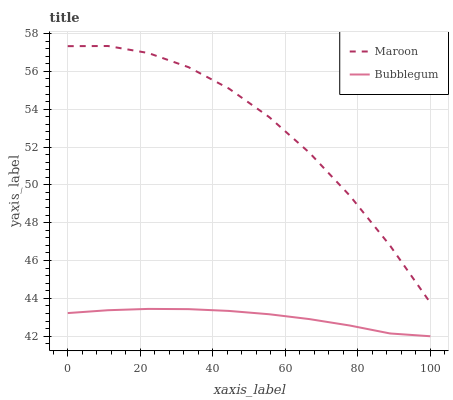Does Bubblegum have the minimum area under the curve?
Answer yes or no. Yes. Does Maroon have the maximum area under the curve?
Answer yes or no. Yes. Does Maroon have the minimum area under the curve?
Answer yes or no. No. Is Bubblegum the smoothest?
Answer yes or no. Yes. Is Maroon the roughest?
Answer yes or no. Yes. Is Maroon the smoothest?
Answer yes or no. No. Does Bubblegum have the lowest value?
Answer yes or no. Yes. Does Maroon have the lowest value?
Answer yes or no. No. Does Maroon have the highest value?
Answer yes or no. Yes. Is Bubblegum less than Maroon?
Answer yes or no. Yes. Is Maroon greater than Bubblegum?
Answer yes or no. Yes. Does Bubblegum intersect Maroon?
Answer yes or no. No. 